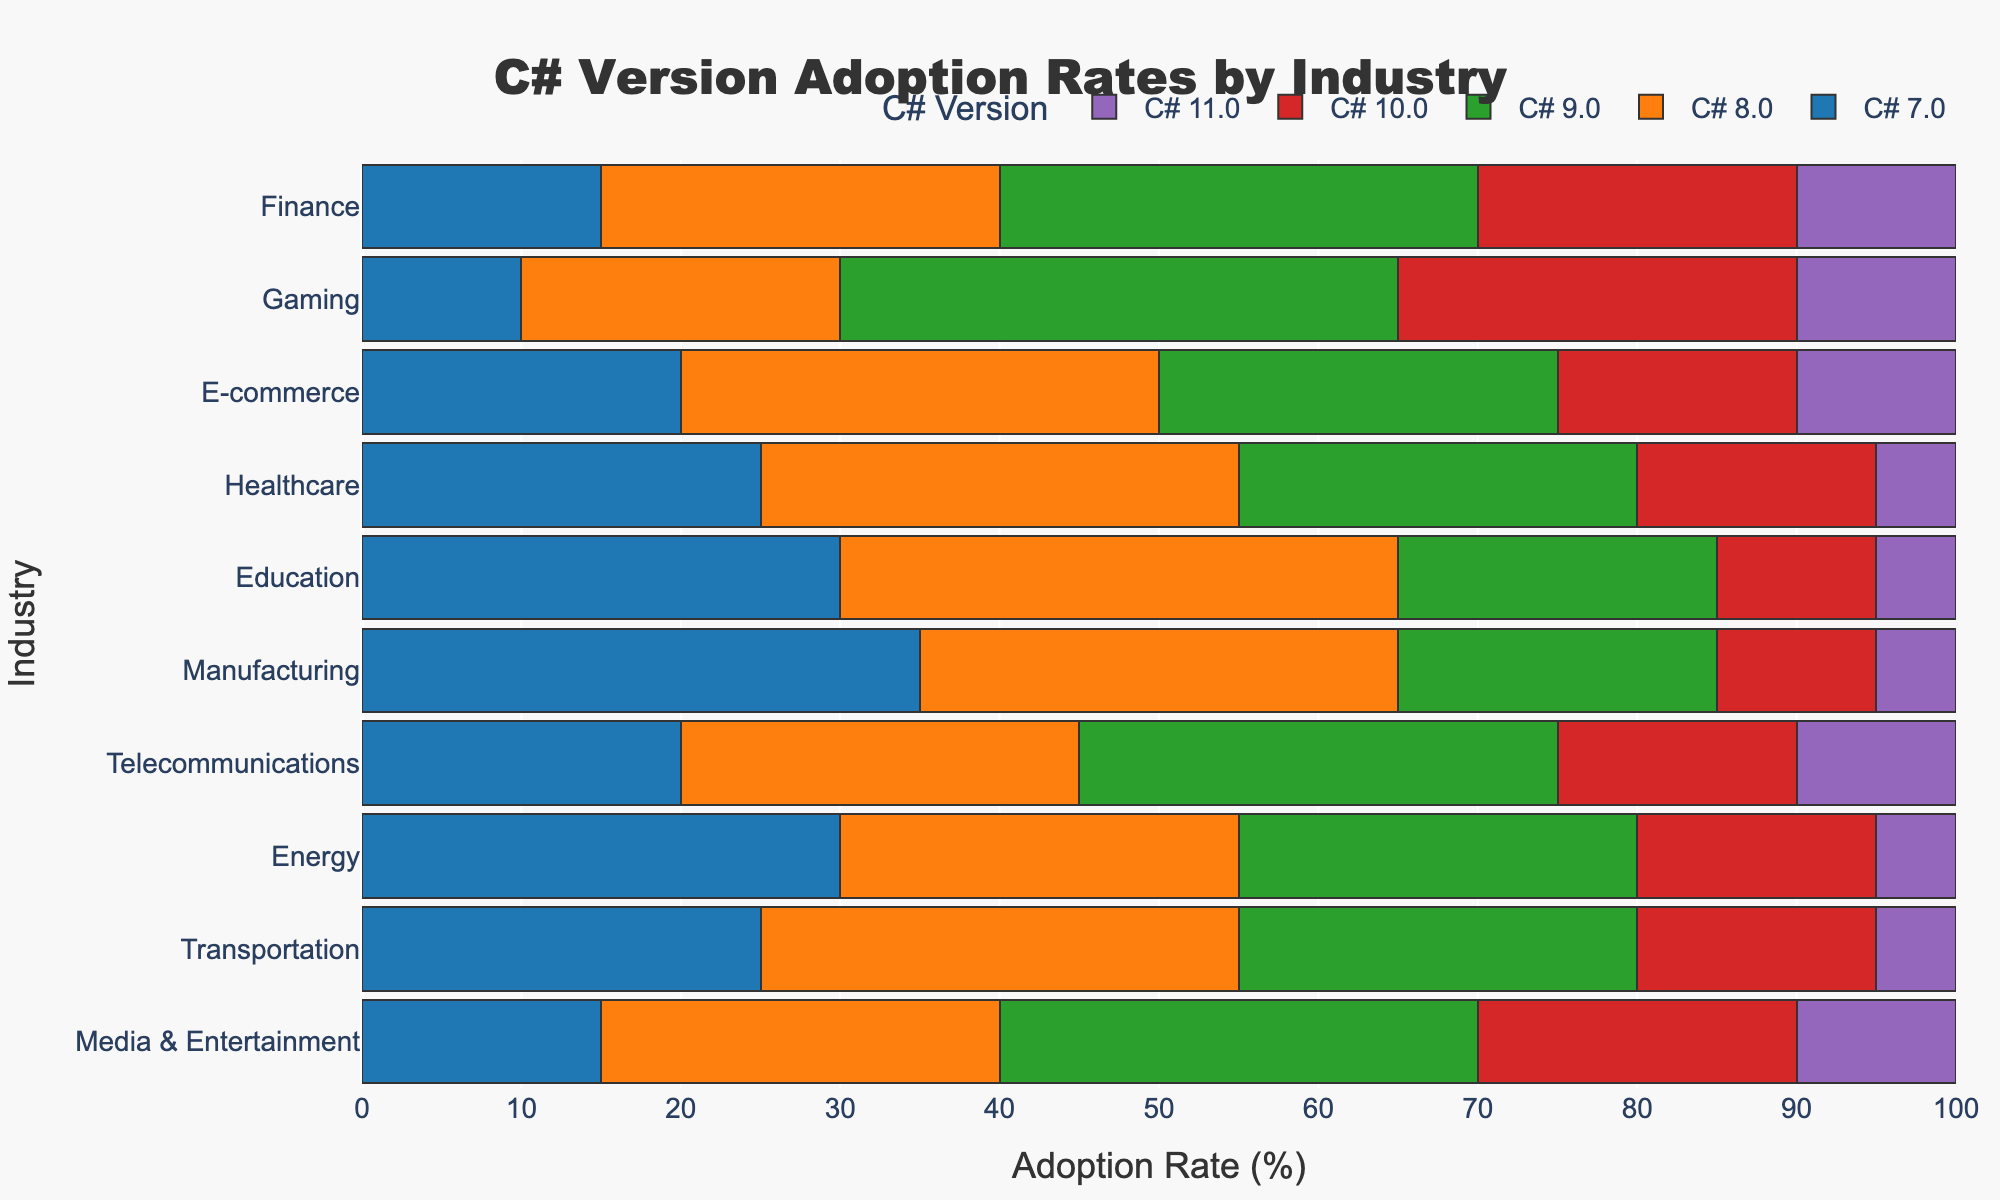What is the title of the figure? The title is shown prominently at the top of the figure.
Answer: C# Version Adoption Rates by Industry Which C# versions are listed in the legend? The legend at the bottom of the figure shows the different C# versions with corresponding colors. They are C# 7.0, C# 8.0, C# 9.0, C# 10.0, and C# 11.0.
Answer: C# 7.0, C# 8.0, C# 9.0, C# 10.0, C# 11.0 Which industry has the highest adoption rate of C# 7.0? Looking at the first section of the bars for each industry, Manufacturing has the longest bar for C# 7.0.
Answer: Manufacturing What is the total adoption rate for C# 8.0 in the Financial and Gaming industries? Sum the percentages for C# 8.0 in the Financial (25%) and Gaming (20%) industries to get the total adoption rate.
Answer: 45% Which industry uses C# 10.0 the least? From the chart, look for the smallest section of the bars corresponding to C# 10.0. The Education, Healthcare, Manufacturing, Energy, and Transportation industries all have the lowest adoption rate of 10% for C# 10.0.
Answer: Education, Healthcare, Manufacturing, Energy, Transportation Which C# version is most popular in the E-commerce industry? Identify the longest section of the bar for the E-commerce industry. The longest bar corresponds to C# 8.0.
Answer: C# 8.0 In which industry is the adoption rate of C# 9.0 equal to the rate in the Telecommunications industry? Both the Media & Entertainment and the Telecommunications industries have a 30% adoption rate for C# 9.0, as indicated by the length of the respective bars.
Answer: Media & Entertainment Compare the adoption rate of C# 11.0 in the Healthcare and Telecommunications industries. Healthcare has a 5% adoption rate for C# 11.0, whereas Telecommunications has a 10% adoption rate. Hence, Telecommunications has a higher rate.
Answer: Telecommunications Which industry is the top adopter of C# 9.0? The Gaming industry has the bar section for C# 9.0 extended the most (35%), indicating it’s the top adopter.
Answer: Gaming How does the adoption rate for C# 8.0 in the Education industry compare to Finance? Compare the lengths of the bar sections for C# 8.0 in both industries, Education has 35% adoption whereas Finance has 25%, so Education has a higher rate.
Answer: Education 